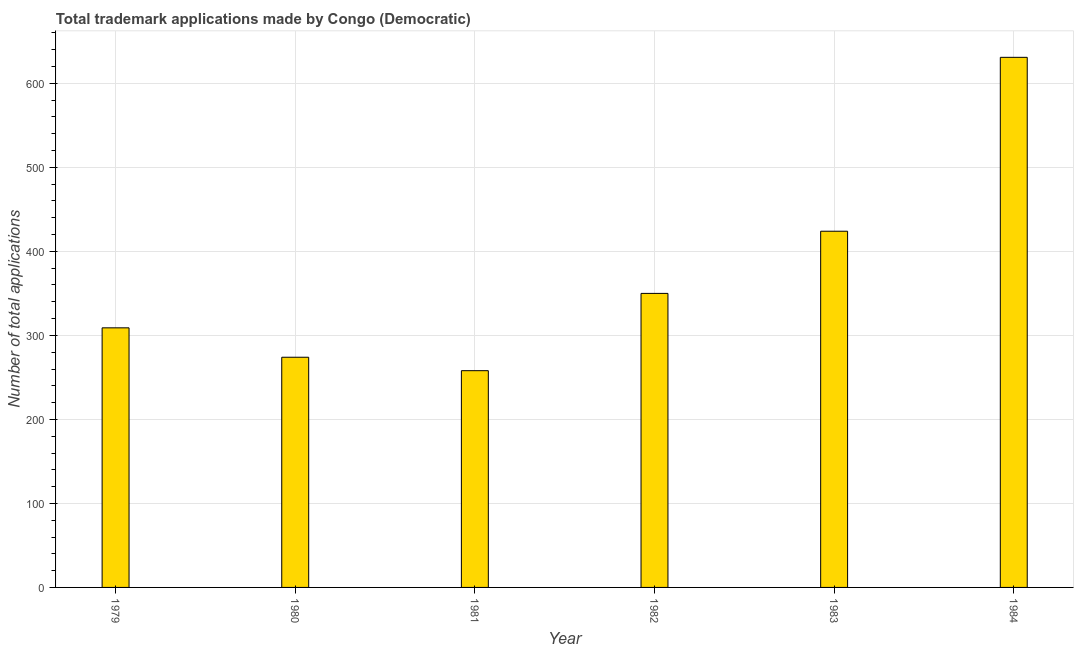Does the graph contain any zero values?
Keep it short and to the point. No. Does the graph contain grids?
Keep it short and to the point. Yes. What is the title of the graph?
Provide a short and direct response. Total trademark applications made by Congo (Democratic). What is the label or title of the X-axis?
Offer a terse response. Year. What is the label or title of the Y-axis?
Make the answer very short. Number of total applications. What is the number of trademark applications in 1981?
Keep it short and to the point. 258. Across all years, what is the maximum number of trademark applications?
Your response must be concise. 631. Across all years, what is the minimum number of trademark applications?
Ensure brevity in your answer.  258. In which year was the number of trademark applications maximum?
Give a very brief answer. 1984. In which year was the number of trademark applications minimum?
Offer a terse response. 1981. What is the sum of the number of trademark applications?
Your answer should be very brief. 2246. What is the difference between the number of trademark applications in 1983 and 1984?
Your answer should be very brief. -207. What is the average number of trademark applications per year?
Your answer should be compact. 374. What is the median number of trademark applications?
Your answer should be compact. 329.5. What is the ratio of the number of trademark applications in 1979 to that in 1984?
Keep it short and to the point. 0.49. Is the number of trademark applications in 1981 less than that in 1984?
Make the answer very short. Yes. Is the difference between the number of trademark applications in 1982 and 1983 greater than the difference between any two years?
Provide a short and direct response. No. What is the difference between the highest and the second highest number of trademark applications?
Make the answer very short. 207. Is the sum of the number of trademark applications in 1979 and 1982 greater than the maximum number of trademark applications across all years?
Ensure brevity in your answer.  Yes. What is the difference between the highest and the lowest number of trademark applications?
Ensure brevity in your answer.  373. In how many years, is the number of trademark applications greater than the average number of trademark applications taken over all years?
Keep it short and to the point. 2. How many bars are there?
Offer a terse response. 6. Are all the bars in the graph horizontal?
Offer a very short reply. No. What is the Number of total applications of 1979?
Keep it short and to the point. 309. What is the Number of total applications in 1980?
Keep it short and to the point. 274. What is the Number of total applications in 1981?
Provide a succinct answer. 258. What is the Number of total applications of 1982?
Your answer should be very brief. 350. What is the Number of total applications of 1983?
Your answer should be very brief. 424. What is the Number of total applications of 1984?
Provide a succinct answer. 631. What is the difference between the Number of total applications in 1979 and 1981?
Your response must be concise. 51. What is the difference between the Number of total applications in 1979 and 1982?
Offer a very short reply. -41. What is the difference between the Number of total applications in 1979 and 1983?
Keep it short and to the point. -115. What is the difference between the Number of total applications in 1979 and 1984?
Offer a terse response. -322. What is the difference between the Number of total applications in 1980 and 1982?
Give a very brief answer. -76. What is the difference between the Number of total applications in 1980 and 1983?
Offer a very short reply. -150. What is the difference between the Number of total applications in 1980 and 1984?
Your response must be concise. -357. What is the difference between the Number of total applications in 1981 and 1982?
Provide a short and direct response. -92. What is the difference between the Number of total applications in 1981 and 1983?
Give a very brief answer. -166. What is the difference between the Number of total applications in 1981 and 1984?
Your answer should be compact. -373. What is the difference between the Number of total applications in 1982 and 1983?
Provide a short and direct response. -74. What is the difference between the Number of total applications in 1982 and 1984?
Offer a very short reply. -281. What is the difference between the Number of total applications in 1983 and 1984?
Ensure brevity in your answer.  -207. What is the ratio of the Number of total applications in 1979 to that in 1980?
Keep it short and to the point. 1.13. What is the ratio of the Number of total applications in 1979 to that in 1981?
Your answer should be compact. 1.2. What is the ratio of the Number of total applications in 1979 to that in 1982?
Provide a short and direct response. 0.88. What is the ratio of the Number of total applications in 1979 to that in 1983?
Provide a succinct answer. 0.73. What is the ratio of the Number of total applications in 1979 to that in 1984?
Your answer should be very brief. 0.49. What is the ratio of the Number of total applications in 1980 to that in 1981?
Your response must be concise. 1.06. What is the ratio of the Number of total applications in 1980 to that in 1982?
Your response must be concise. 0.78. What is the ratio of the Number of total applications in 1980 to that in 1983?
Your answer should be compact. 0.65. What is the ratio of the Number of total applications in 1980 to that in 1984?
Make the answer very short. 0.43. What is the ratio of the Number of total applications in 1981 to that in 1982?
Your answer should be very brief. 0.74. What is the ratio of the Number of total applications in 1981 to that in 1983?
Make the answer very short. 0.61. What is the ratio of the Number of total applications in 1981 to that in 1984?
Ensure brevity in your answer.  0.41. What is the ratio of the Number of total applications in 1982 to that in 1983?
Your response must be concise. 0.82. What is the ratio of the Number of total applications in 1982 to that in 1984?
Provide a short and direct response. 0.56. What is the ratio of the Number of total applications in 1983 to that in 1984?
Give a very brief answer. 0.67. 